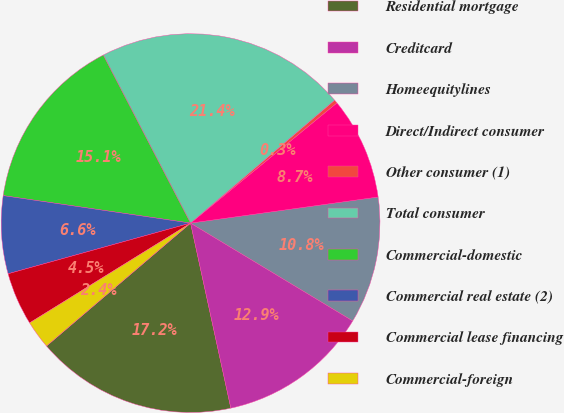Convert chart. <chart><loc_0><loc_0><loc_500><loc_500><pie_chart><fcel>Residential mortgage<fcel>Creditcard<fcel>Homeequitylines<fcel>Direct/Indirect consumer<fcel>Other consumer (1)<fcel>Total consumer<fcel>Commercial-domestic<fcel>Commercial real estate (2)<fcel>Commercial lease financing<fcel>Commercial-foreign<nl><fcel>17.17%<fcel>12.95%<fcel>10.84%<fcel>8.74%<fcel>0.3%<fcel>21.38%<fcel>15.06%<fcel>6.63%<fcel>4.52%<fcel>2.41%<nl></chart> 